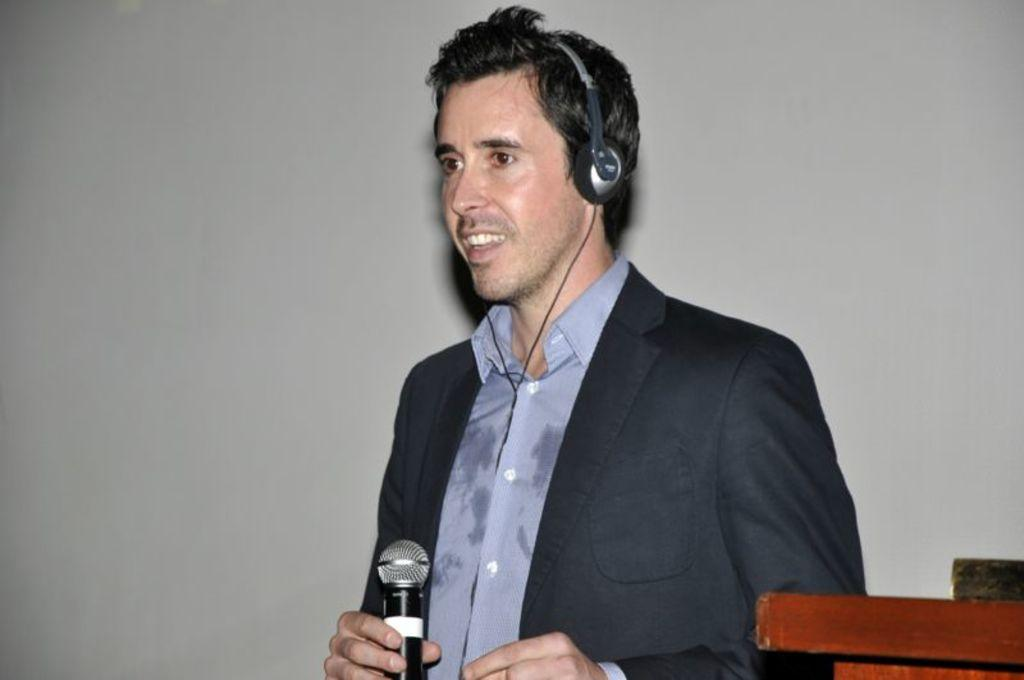What is the person in the image wearing? The person is wearing a suit and headphones. What is the person holding in the image? The person is holding a microphone. Can you describe the wooden item in the right bottom of the image? There is a wooden item in the right bottom of the image, but its specific details are not clear from the provided facts. How many pizzas are being rewarded to the person in the image? There is no mention of pizzas or rewards in the image or the provided facts. 